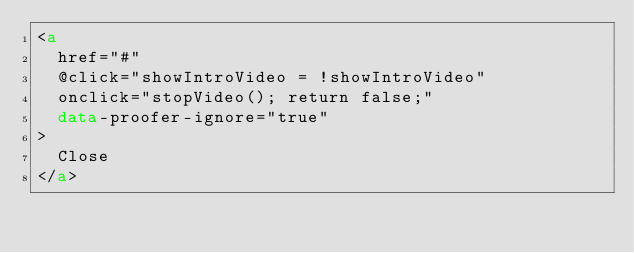Convert code to text. <code><loc_0><loc_0><loc_500><loc_500><_HTML_><a
  href="#"
  @click="showIntroVideo = !showIntroVideo"
  onclick="stopVideo(); return false;"
  data-proofer-ignore="true"
>
  Close
</a>
</code> 